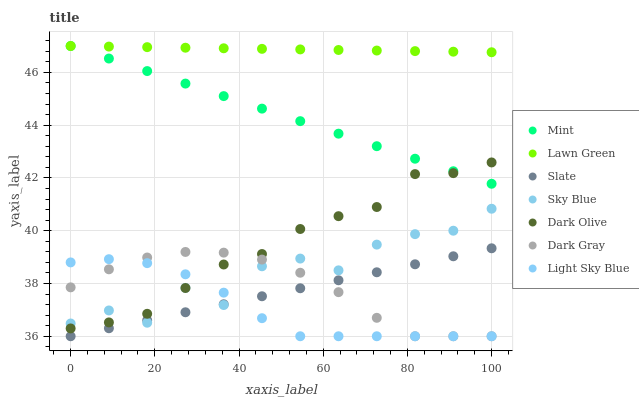Does Light Sky Blue have the minimum area under the curve?
Answer yes or no. Yes. Does Lawn Green have the maximum area under the curve?
Answer yes or no. Yes. Does Slate have the minimum area under the curve?
Answer yes or no. No. Does Slate have the maximum area under the curve?
Answer yes or no. No. Is Mint the smoothest?
Answer yes or no. Yes. Is Sky Blue the roughest?
Answer yes or no. Yes. Is Slate the smoothest?
Answer yes or no. No. Is Slate the roughest?
Answer yes or no. No. Does Slate have the lowest value?
Answer yes or no. Yes. Does Dark Olive have the lowest value?
Answer yes or no. No. Does Mint have the highest value?
Answer yes or no. Yes. Does Slate have the highest value?
Answer yes or no. No. Is Light Sky Blue less than Mint?
Answer yes or no. Yes. Is Mint greater than Light Sky Blue?
Answer yes or no. Yes. Does Dark Gray intersect Slate?
Answer yes or no. Yes. Is Dark Gray less than Slate?
Answer yes or no. No. Is Dark Gray greater than Slate?
Answer yes or no. No. Does Light Sky Blue intersect Mint?
Answer yes or no. No. 